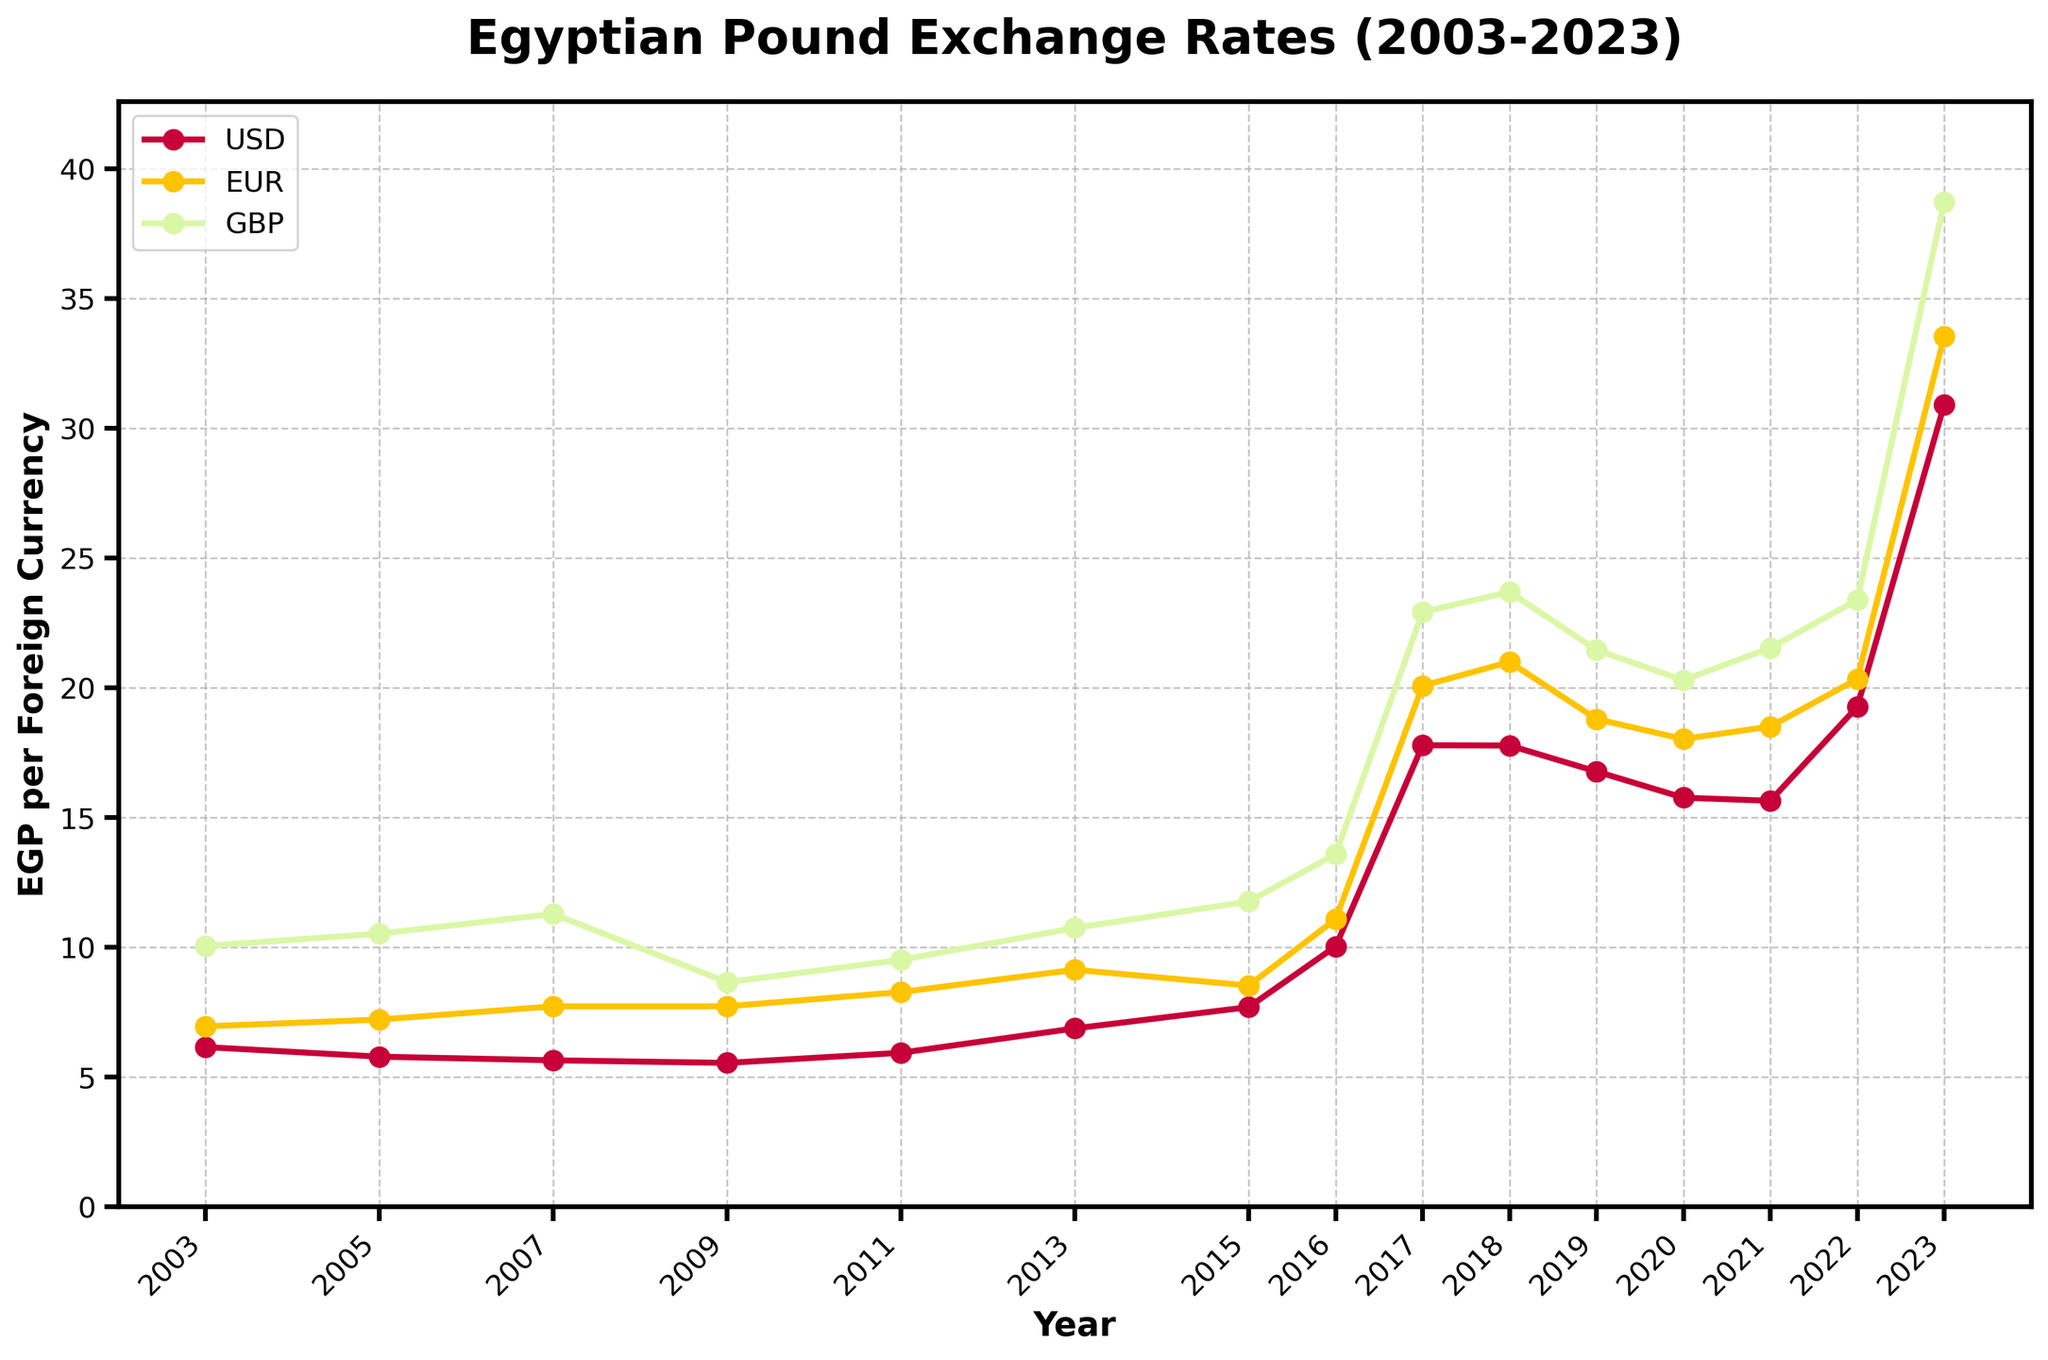What was the exchange rate of 1 USD to EGP in 2023? The figure shows the exchange rates over the years, and by looking at the year 2023, the exchange rate for USD is indicated.
Answer: 30.90 How did the exchange rate of EGP/USD change from 2016 to 2017? To find the change, look at the exchange rate for EGP/USD in 2016 and 2017, then calculate the difference: 17.78 (2017) - 10.03 (2016).
Answer: Increased by 7.75 Which currency had the highest exchange rate against EGP in 2007? The highest exchange rate is determined by comparing the 2007 values for USD, EUR, and GBP. GBP has the highest value: 11.28.
Answer: GBP What was the average exchange rate of EGP/USD over the past 5 years (2019-2023)? To calculate the average, sum the EGP/USD exchange rates for the years 2019 to 2023, then divide by the number of years: (16.77 + 15.76 + 15.64 + 19.26 + 30.90) / 5 = 19.66.
Answer: 19.66 Which currency saw the highest increase in exchange rates against the EGP from 2022 to 2023? Calculate the increase for each currency by subtracting the 2022 value from the 2023 value and compare: USD (30.90 - 19.26), EUR (33.53 - 20.33), GBP (38.71 - 23.38). GBP has the largest increase.
Answer: GBP Between which years did the EGP experience the most significant decrease in value against the EUR? By comparing the difference in EGP/EUR values between consecutive years, the most significant increase (indicating a decrease in EGP value) is from 2016 to 2017 (20.07 - 11.08).
Answer: 2016 to 2017 What is the overall trend in EGP/USD from 2003 to 2023? Observing the graph, the EGP/USD exchange rate shows an overall increasing trend, indicating a consistent decrease in the value of the EGP against the USD.
Answer: Increasing Compare the EGP/GBP exchange rate in 2011 and 2017, which year had a higher value? By looking at the values given on the graph, EGP/GBP was 9.51 in 2011 and 22.91 in 2017. 2017 had a higher value.
Answer: 2017 